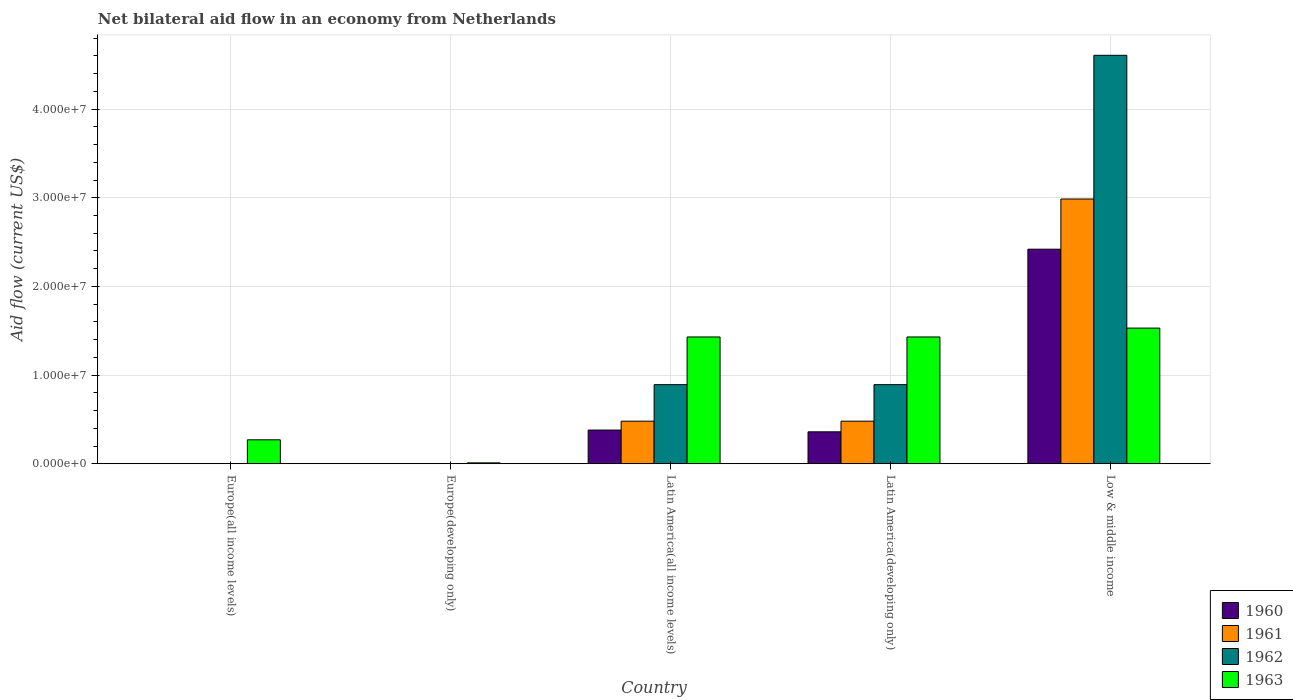Are the number of bars on each tick of the X-axis equal?
Keep it short and to the point. No. How many bars are there on the 4th tick from the left?
Give a very brief answer. 4. What is the label of the 2nd group of bars from the left?
Your response must be concise. Europe(developing only). In how many cases, is the number of bars for a given country not equal to the number of legend labels?
Your answer should be compact. 2. Across all countries, what is the maximum net bilateral aid flow in 1960?
Offer a very short reply. 2.42e+07. Across all countries, what is the minimum net bilateral aid flow in 1963?
Your answer should be compact. 1.00e+05. In which country was the net bilateral aid flow in 1963 maximum?
Offer a very short reply. Low & middle income. What is the total net bilateral aid flow in 1963 in the graph?
Keep it short and to the point. 4.67e+07. What is the difference between the net bilateral aid flow in 1960 in Latin America(developing only) and that in Low & middle income?
Your answer should be very brief. -2.06e+07. What is the difference between the net bilateral aid flow in 1960 in Europe(all income levels) and the net bilateral aid flow in 1962 in Low & middle income?
Your answer should be compact. -4.61e+07. What is the average net bilateral aid flow in 1961 per country?
Your response must be concise. 7.89e+06. What is the difference between the net bilateral aid flow of/in 1960 and net bilateral aid flow of/in 1963 in Latin America(all income levels)?
Make the answer very short. -1.05e+07. What is the ratio of the net bilateral aid flow in 1963 in Europe(all income levels) to that in Latin America(all income levels)?
Provide a short and direct response. 0.19. Is the difference between the net bilateral aid flow in 1960 in Latin America(all income levels) and Latin America(developing only) greater than the difference between the net bilateral aid flow in 1963 in Latin America(all income levels) and Latin America(developing only)?
Provide a short and direct response. Yes. What is the difference between the highest and the second highest net bilateral aid flow in 1961?
Your answer should be very brief. 2.51e+07. What is the difference between the highest and the lowest net bilateral aid flow in 1961?
Offer a very short reply. 2.99e+07. Is it the case that in every country, the sum of the net bilateral aid flow in 1960 and net bilateral aid flow in 1962 is greater than the sum of net bilateral aid flow in 1961 and net bilateral aid flow in 1963?
Make the answer very short. No. Is it the case that in every country, the sum of the net bilateral aid flow in 1961 and net bilateral aid flow in 1960 is greater than the net bilateral aid flow in 1963?
Provide a succinct answer. No. Are all the bars in the graph horizontal?
Offer a very short reply. No. Does the graph contain any zero values?
Offer a terse response. Yes. Where does the legend appear in the graph?
Keep it short and to the point. Bottom right. How many legend labels are there?
Give a very brief answer. 4. How are the legend labels stacked?
Make the answer very short. Vertical. What is the title of the graph?
Offer a terse response. Net bilateral aid flow in an economy from Netherlands. Does "1991" appear as one of the legend labels in the graph?
Provide a succinct answer. No. What is the Aid flow (current US$) of 1960 in Europe(all income levels)?
Keep it short and to the point. 0. What is the Aid flow (current US$) in 1961 in Europe(all income levels)?
Ensure brevity in your answer.  0. What is the Aid flow (current US$) in 1962 in Europe(all income levels)?
Ensure brevity in your answer.  0. What is the Aid flow (current US$) of 1963 in Europe(all income levels)?
Your answer should be compact. 2.70e+06. What is the Aid flow (current US$) of 1960 in Europe(developing only)?
Offer a terse response. 0. What is the Aid flow (current US$) of 1961 in Europe(developing only)?
Your answer should be compact. 0. What is the Aid flow (current US$) of 1962 in Europe(developing only)?
Offer a very short reply. 0. What is the Aid flow (current US$) in 1960 in Latin America(all income levels)?
Provide a short and direct response. 3.80e+06. What is the Aid flow (current US$) in 1961 in Latin America(all income levels)?
Keep it short and to the point. 4.80e+06. What is the Aid flow (current US$) of 1962 in Latin America(all income levels)?
Your answer should be very brief. 8.92e+06. What is the Aid flow (current US$) in 1963 in Latin America(all income levels)?
Provide a succinct answer. 1.43e+07. What is the Aid flow (current US$) in 1960 in Latin America(developing only)?
Give a very brief answer. 3.60e+06. What is the Aid flow (current US$) of 1961 in Latin America(developing only)?
Offer a terse response. 4.80e+06. What is the Aid flow (current US$) in 1962 in Latin America(developing only)?
Keep it short and to the point. 8.92e+06. What is the Aid flow (current US$) of 1963 in Latin America(developing only)?
Make the answer very short. 1.43e+07. What is the Aid flow (current US$) of 1960 in Low & middle income?
Your answer should be compact. 2.42e+07. What is the Aid flow (current US$) in 1961 in Low & middle income?
Provide a short and direct response. 2.99e+07. What is the Aid flow (current US$) in 1962 in Low & middle income?
Offer a terse response. 4.61e+07. What is the Aid flow (current US$) of 1963 in Low & middle income?
Give a very brief answer. 1.53e+07. Across all countries, what is the maximum Aid flow (current US$) of 1960?
Give a very brief answer. 2.42e+07. Across all countries, what is the maximum Aid flow (current US$) of 1961?
Provide a short and direct response. 2.99e+07. Across all countries, what is the maximum Aid flow (current US$) of 1962?
Your answer should be very brief. 4.61e+07. Across all countries, what is the maximum Aid flow (current US$) in 1963?
Provide a succinct answer. 1.53e+07. Across all countries, what is the minimum Aid flow (current US$) in 1960?
Make the answer very short. 0. Across all countries, what is the minimum Aid flow (current US$) in 1962?
Offer a terse response. 0. Across all countries, what is the minimum Aid flow (current US$) of 1963?
Make the answer very short. 1.00e+05. What is the total Aid flow (current US$) in 1960 in the graph?
Offer a terse response. 3.16e+07. What is the total Aid flow (current US$) in 1961 in the graph?
Offer a terse response. 3.95e+07. What is the total Aid flow (current US$) in 1962 in the graph?
Your response must be concise. 6.39e+07. What is the total Aid flow (current US$) of 1963 in the graph?
Your answer should be very brief. 4.67e+07. What is the difference between the Aid flow (current US$) in 1963 in Europe(all income levels) and that in Europe(developing only)?
Your answer should be compact. 2.60e+06. What is the difference between the Aid flow (current US$) in 1963 in Europe(all income levels) and that in Latin America(all income levels)?
Your response must be concise. -1.16e+07. What is the difference between the Aid flow (current US$) of 1963 in Europe(all income levels) and that in Latin America(developing only)?
Your answer should be very brief. -1.16e+07. What is the difference between the Aid flow (current US$) in 1963 in Europe(all income levels) and that in Low & middle income?
Make the answer very short. -1.26e+07. What is the difference between the Aid flow (current US$) of 1963 in Europe(developing only) and that in Latin America(all income levels)?
Provide a short and direct response. -1.42e+07. What is the difference between the Aid flow (current US$) in 1963 in Europe(developing only) and that in Latin America(developing only)?
Offer a terse response. -1.42e+07. What is the difference between the Aid flow (current US$) of 1963 in Europe(developing only) and that in Low & middle income?
Provide a short and direct response. -1.52e+07. What is the difference between the Aid flow (current US$) of 1961 in Latin America(all income levels) and that in Latin America(developing only)?
Make the answer very short. 0. What is the difference between the Aid flow (current US$) of 1963 in Latin America(all income levels) and that in Latin America(developing only)?
Offer a very short reply. 0. What is the difference between the Aid flow (current US$) in 1960 in Latin America(all income levels) and that in Low & middle income?
Give a very brief answer. -2.04e+07. What is the difference between the Aid flow (current US$) of 1961 in Latin America(all income levels) and that in Low & middle income?
Your response must be concise. -2.51e+07. What is the difference between the Aid flow (current US$) of 1962 in Latin America(all income levels) and that in Low & middle income?
Make the answer very short. -3.72e+07. What is the difference between the Aid flow (current US$) in 1963 in Latin America(all income levels) and that in Low & middle income?
Provide a succinct answer. -1.00e+06. What is the difference between the Aid flow (current US$) of 1960 in Latin America(developing only) and that in Low & middle income?
Make the answer very short. -2.06e+07. What is the difference between the Aid flow (current US$) of 1961 in Latin America(developing only) and that in Low & middle income?
Keep it short and to the point. -2.51e+07. What is the difference between the Aid flow (current US$) of 1962 in Latin America(developing only) and that in Low & middle income?
Give a very brief answer. -3.72e+07. What is the difference between the Aid flow (current US$) of 1963 in Latin America(developing only) and that in Low & middle income?
Offer a very short reply. -1.00e+06. What is the difference between the Aid flow (current US$) in 1960 in Latin America(all income levels) and the Aid flow (current US$) in 1961 in Latin America(developing only)?
Your response must be concise. -1.00e+06. What is the difference between the Aid flow (current US$) in 1960 in Latin America(all income levels) and the Aid flow (current US$) in 1962 in Latin America(developing only)?
Provide a succinct answer. -5.12e+06. What is the difference between the Aid flow (current US$) of 1960 in Latin America(all income levels) and the Aid flow (current US$) of 1963 in Latin America(developing only)?
Provide a succinct answer. -1.05e+07. What is the difference between the Aid flow (current US$) of 1961 in Latin America(all income levels) and the Aid flow (current US$) of 1962 in Latin America(developing only)?
Give a very brief answer. -4.12e+06. What is the difference between the Aid flow (current US$) in 1961 in Latin America(all income levels) and the Aid flow (current US$) in 1963 in Latin America(developing only)?
Offer a very short reply. -9.50e+06. What is the difference between the Aid flow (current US$) in 1962 in Latin America(all income levels) and the Aid flow (current US$) in 1963 in Latin America(developing only)?
Provide a succinct answer. -5.38e+06. What is the difference between the Aid flow (current US$) in 1960 in Latin America(all income levels) and the Aid flow (current US$) in 1961 in Low & middle income?
Provide a succinct answer. -2.61e+07. What is the difference between the Aid flow (current US$) of 1960 in Latin America(all income levels) and the Aid flow (current US$) of 1962 in Low & middle income?
Your answer should be very brief. -4.23e+07. What is the difference between the Aid flow (current US$) of 1960 in Latin America(all income levels) and the Aid flow (current US$) of 1963 in Low & middle income?
Offer a very short reply. -1.15e+07. What is the difference between the Aid flow (current US$) in 1961 in Latin America(all income levels) and the Aid flow (current US$) in 1962 in Low & middle income?
Ensure brevity in your answer.  -4.13e+07. What is the difference between the Aid flow (current US$) of 1961 in Latin America(all income levels) and the Aid flow (current US$) of 1963 in Low & middle income?
Your answer should be compact. -1.05e+07. What is the difference between the Aid flow (current US$) of 1962 in Latin America(all income levels) and the Aid flow (current US$) of 1963 in Low & middle income?
Your answer should be very brief. -6.38e+06. What is the difference between the Aid flow (current US$) in 1960 in Latin America(developing only) and the Aid flow (current US$) in 1961 in Low & middle income?
Ensure brevity in your answer.  -2.63e+07. What is the difference between the Aid flow (current US$) in 1960 in Latin America(developing only) and the Aid flow (current US$) in 1962 in Low & middle income?
Provide a succinct answer. -4.25e+07. What is the difference between the Aid flow (current US$) of 1960 in Latin America(developing only) and the Aid flow (current US$) of 1963 in Low & middle income?
Give a very brief answer. -1.17e+07. What is the difference between the Aid flow (current US$) of 1961 in Latin America(developing only) and the Aid flow (current US$) of 1962 in Low & middle income?
Your response must be concise. -4.13e+07. What is the difference between the Aid flow (current US$) in 1961 in Latin America(developing only) and the Aid flow (current US$) in 1963 in Low & middle income?
Your response must be concise. -1.05e+07. What is the difference between the Aid flow (current US$) of 1962 in Latin America(developing only) and the Aid flow (current US$) of 1963 in Low & middle income?
Offer a very short reply. -6.38e+06. What is the average Aid flow (current US$) in 1960 per country?
Make the answer very short. 6.32e+06. What is the average Aid flow (current US$) of 1961 per country?
Your answer should be compact. 7.89e+06. What is the average Aid flow (current US$) in 1962 per country?
Provide a short and direct response. 1.28e+07. What is the average Aid flow (current US$) of 1963 per country?
Ensure brevity in your answer.  9.34e+06. What is the difference between the Aid flow (current US$) of 1960 and Aid flow (current US$) of 1961 in Latin America(all income levels)?
Keep it short and to the point. -1.00e+06. What is the difference between the Aid flow (current US$) in 1960 and Aid flow (current US$) in 1962 in Latin America(all income levels)?
Provide a short and direct response. -5.12e+06. What is the difference between the Aid flow (current US$) of 1960 and Aid flow (current US$) of 1963 in Latin America(all income levels)?
Your answer should be very brief. -1.05e+07. What is the difference between the Aid flow (current US$) in 1961 and Aid flow (current US$) in 1962 in Latin America(all income levels)?
Your answer should be compact. -4.12e+06. What is the difference between the Aid flow (current US$) in 1961 and Aid flow (current US$) in 1963 in Latin America(all income levels)?
Ensure brevity in your answer.  -9.50e+06. What is the difference between the Aid flow (current US$) of 1962 and Aid flow (current US$) of 1963 in Latin America(all income levels)?
Keep it short and to the point. -5.38e+06. What is the difference between the Aid flow (current US$) of 1960 and Aid flow (current US$) of 1961 in Latin America(developing only)?
Your response must be concise. -1.20e+06. What is the difference between the Aid flow (current US$) in 1960 and Aid flow (current US$) in 1962 in Latin America(developing only)?
Provide a short and direct response. -5.32e+06. What is the difference between the Aid flow (current US$) in 1960 and Aid flow (current US$) in 1963 in Latin America(developing only)?
Offer a very short reply. -1.07e+07. What is the difference between the Aid flow (current US$) of 1961 and Aid flow (current US$) of 1962 in Latin America(developing only)?
Give a very brief answer. -4.12e+06. What is the difference between the Aid flow (current US$) of 1961 and Aid flow (current US$) of 1963 in Latin America(developing only)?
Offer a very short reply. -9.50e+06. What is the difference between the Aid flow (current US$) in 1962 and Aid flow (current US$) in 1963 in Latin America(developing only)?
Ensure brevity in your answer.  -5.38e+06. What is the difference between the Aid flow (current US$) in 1960 and Aid flow (current US$) in 1961 in Low & middle income?
Make the answer very short. -5.66e+06. What is the difference between the Aid flow (current US$) in 1960 and Aid flow (current US$) in 1962 in Low & middle income?
Your answer should be very brief. -2.19e+07. What is the difference between the Aid flow (current US$) of 1960 and Aid flow (current US$) of 1963 in Low & middle income?
Offer a terse response. 8.90e+06. What is the difference between the Aid flow (current US$) of 1961 and Aid flow (current US$) of 1962 in Low & middle income?
Provide a short and direct response. -1.62e+07. What is the difference between the Aid flow (current US$) in 1961 and Aid flow (current US$) in 1963 in Low & middle income?
Keep it short and to the point. 1.46e+07. What is the difference between the Aid flow (current US$) of 1962 and Aid flow (current US$) of 1963 in Low & middle income?
Provide a short and direct response. 3.08e+07. What is the ratio of the Aid flow (current US$) in 1963 in Europe(all income levels) to that in Latin America(all income levels)?
Your answer should be very brief. 0.19. What is the ratio of the Aid flow (current US$) of 1963 in Europe(all income levels) to that in Latin America(developing only)?
Your response must be concise. 0.19. What is the ratio of the Aid flow (current US$) of 1963 in Europe(all income levels) to that in Low & middle income?
Give a very brief answer. 0.18. What is the ratio of the Aid flow (current US$) in 1963 in Europe(developing only) to that in Latin America(all income levels)?
Ensure brevity in your answer.  0.01. What is the ratio of the Aid flow (current US$) in 1963 in Europe(developing only) to that in Latin America(developing only)?
Offer a terse response. 0.01. What is the ratio of the Aid flow (current US$) in 1963 in Europe(developing only) to that in Low & middle income?
Give a very brief answer. 0.01. What is the ratio of the Aid flow (current US$) of 1960 in Latin America(all income levels) to that in Latin America(developing only)?
Provide a short and direct response. 1.06. What is the ratio of the Aid flow (current US$) in 1962 in Latin America(all income levels) to that in Latin America(developing only)?
Keep it short and to the point. 1. What is the ratio of the Aid flow (current US$) in 1960 in Latin America(all income levels) to that in Low & middle income?
Give a very brief answer. 0.16. What is the ratio of the Aid flow (current US$) in 1961 in Latin America(all income levels) to that in Low & middle income?
Your answer should be very brief. 0.16. What is the ratio of the Aid flow (current US$) of 1962 in Latin America(all income levels) to that in Low & middle income?
Your response must be concise. 0.19. What is the ratio of the Aid flow (current US$) in 1963 in Latin America(all income levels) to that in Low & middle income?
Provide a succinct answer. 0.93. What is the ratio of the Aid flow (current US$) in 1960 in Latin America(developing only) to that in Low & middle income?
Keep it short and to the point. 0.15. What is the ratio of the Aid flow (current US$) in 1961 in Latin America(developing only) to that in Low & middle income?
Provide a short and direct response. 0.16. What is the ratio of the Aid flow (current US$) in 1962 in Latin America(developing only) to that in Low & middle income?
Give a very brief answer. 0.19. What is the ratio of the Aid flow (current US$) of 1963 in Latin America(developing only) to that in Low & middle income?
Provide a succinct answer. 0.93. What is the difference between the highest and the second highest Aid flow (current US$) in 1960?
Make the answer very short. 2.04e+07. What is the difference between the highest and the second highest Aid flow (current US$) of 1961?
Provide a short and direct response. 2.51e+07. What is the difference between the highest and the second highest Aid flow (current US$) of 1962?
Your answer should be compact. 3.72e+07. What is the difference between the highest and the lowest Aid flow (current US$) in 1960?
Offer a terse response. 2.42e+07. What is the difference between the highest and the lowest Aid flow (current US$) of 1961?
Keep it short and to the point. 2.99e+07. What is the difference between the highest and the lowest Aid flow (current US$) in 1962?
Offer a very short reply. 4.61e+07. What is the difference between the highest and the lowest Aid flow (current US$) in 1963?
Provide a succinct answer. 1.52e+07. 